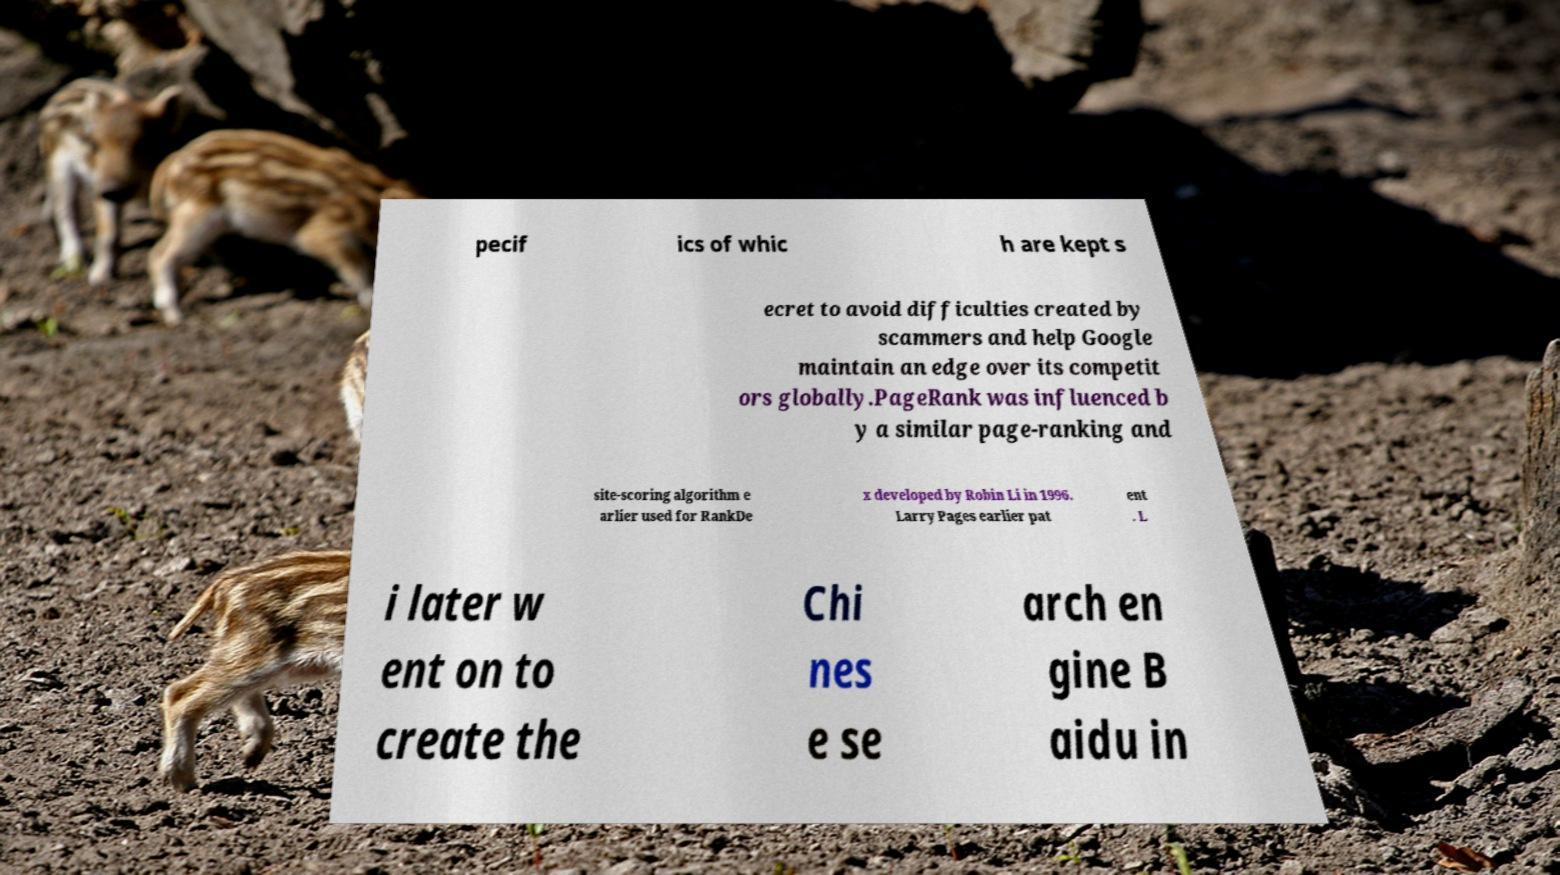For documentation purposes, I need the text within this image transcribed. Could you provide that? pecif ics of whic h are kept s ecret to avoid difficulties created by scammers and help Google maintain an edge over its competit ors globally.PageRank was influenced b y a similar page-ranking and site-scoring algorithm e arlier used for RankDe x developed by Robin Li in 1996. Larry Pages earlier pat ent . L i later w ent on to create the Chi nes e se arch en gine B aidu in 